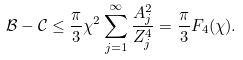<formula> <loc_0><loc_0><loc_500><loc_500>\mathcal { B } - \mathcal { C } \leq \frac { \pi } { 3 } \chi ^ { 2 } \sum _ { j = 1 } ^ { \infty } \frac { A _ { j } ^ { 2 } } { Z _ { j } ^ { 4 } } = \frac { \pi } { 3 } F _ { 4 } ( \chi ) .</formula> 